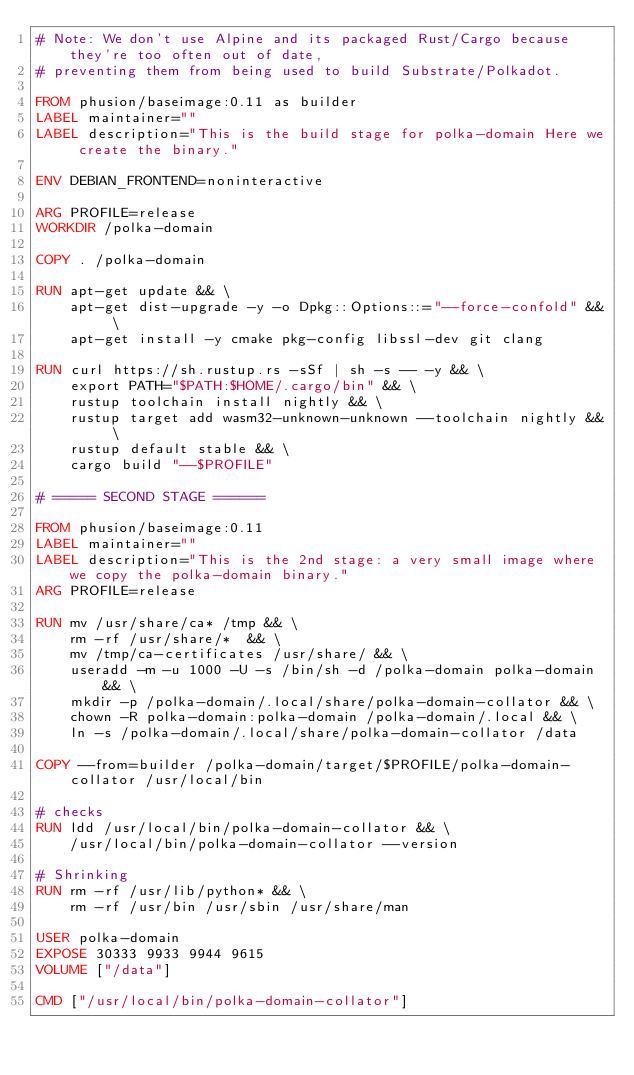Convert code to text. <code><loc_0><loc_0><loc_500><loc_500><_Dockerfile_># Note: We don't use Alpine and its packaged Rust/Cargo because they're too often out of date,
# preventing them from being used to build Substrate/Polkadot.

FROM phusion/baseimage:0.11 as builder
LABEL maintainer=""
LABEL description="This is the build stage for polka-domain Here we create the binary."

ENV DEBIAN_FRONTEND=noninteractive

ARG PROFILE=release
WORKDIR /polka-domain

COPY . /polka-domain

RUN apt-get update && \
	apt-get dist-upgrade -y -o Dpkg::Options::="--force-confold" && \
	apt-get install -y cmake pkg-config libssl-dev git clang

RUN curl https://sh.rustup.rs -sSf | sh -s -- -y && \
	export PATH="$PATH:$HOME/.cargo/bin" && \
	rustup toolchain install nightly && \
	rustup target add wasm32-unknown-unknown --toolchain nightly && \
	rustup default stable && \
	cargo build "--$PROFILE"

# ===== SECOND STAGE ======

FROM phusion/baseimage:0.11
LABEL maintainer=""
LABEL description="This is the 2nd stage: a very small image where we copy the polka-domain binary."
ARG PROFILE=release

RUN mv /usr/share/ca* /tmp && \
	rm -rf /usr/share/*  && \
	mv /tmp/ca-certificates /usr/share/ && \
	useradd -m -u 1000 -U -s /bin/sh -d /polka-domain polka-domain && \
	mkdir -p /polka-domain/.local/share/polka-domain-collator && \
	chown -R polka-domain:polka-domain /polka-domain/.local && \
	ln -s /polka-domain/.local/share/polka-domain-collator /data

COPY --from=builder /polka-domain/target/$PROFILE/polka-domain-collator /usr/local/bin

# checks
RUN ldd /usr/local/bin/polka-domain-collator && \
	/usr/local/bin/polka-domain-collator --version

# Shrinking
RUN rm -rf /usr/lib/python* && \
	rm -rf /usr/bin /usr/sbin /usr/share/man

USER polka-domain
EXPOSE 30333 9933 9944 9615
VOLUME ["/data"]

CMD ["/usr/local/bin/polka-domain-collator"]</code> 